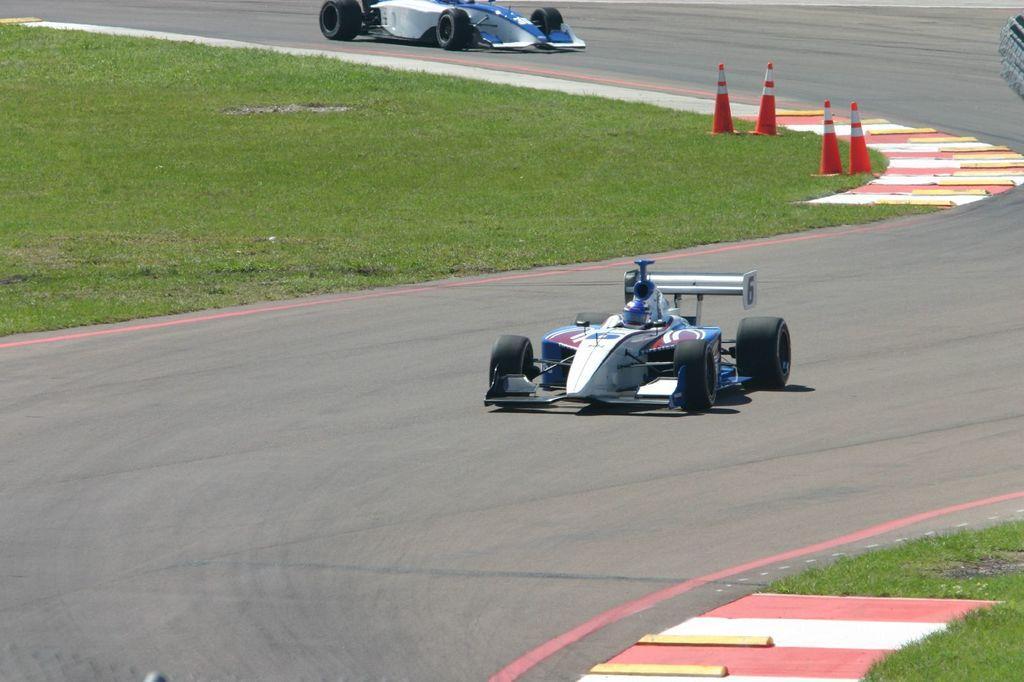In one or two sentences, can you explain what this image depicts? This picture is taken from outside of the city. In this image, in the middle, we can see a vehicle which is moving on the road. Inside the vehicle, we can see a person. In the right corner, we can see a grass and few marbles. On the right side, we can also tire of the vehicle. In the middle of the image, we can also see another vehicle which is moving on the road. On the left side, we can see a grass, marbles and few cones which are placed on the grass. 